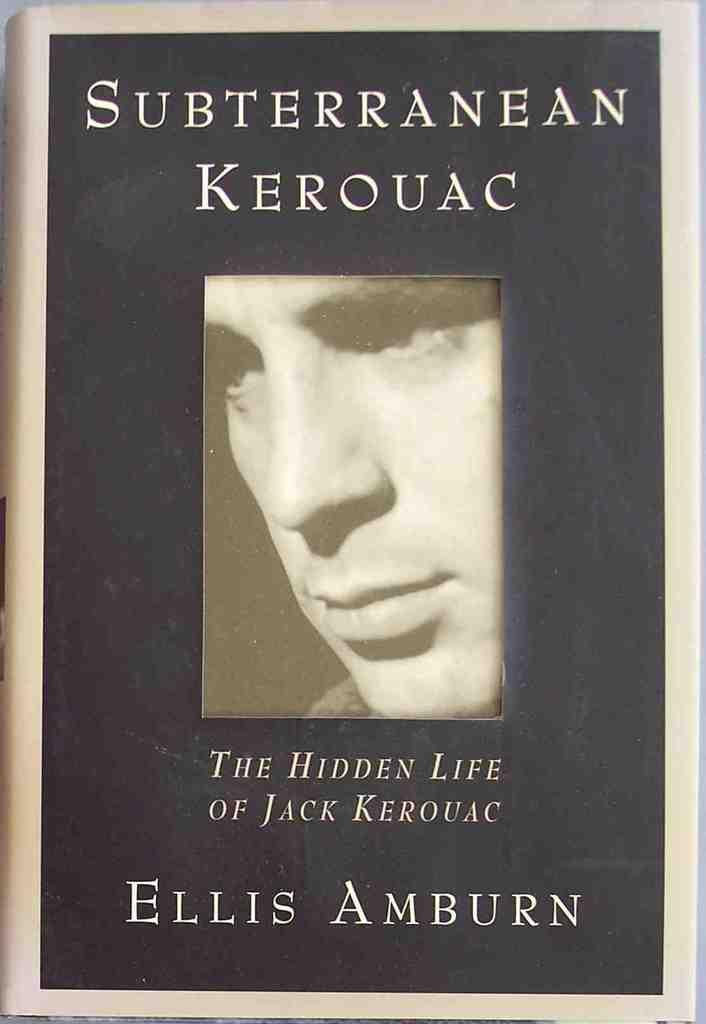What object can be seen in the image? There is a book in the image. What feature is present on the book? A person's face is visible on the book. What can be found on the book besides the person's face? There is text written on the book. How many goldfish are swimming in the book in the image? There are no goldfish present in the image; the book features a person's face and text. 